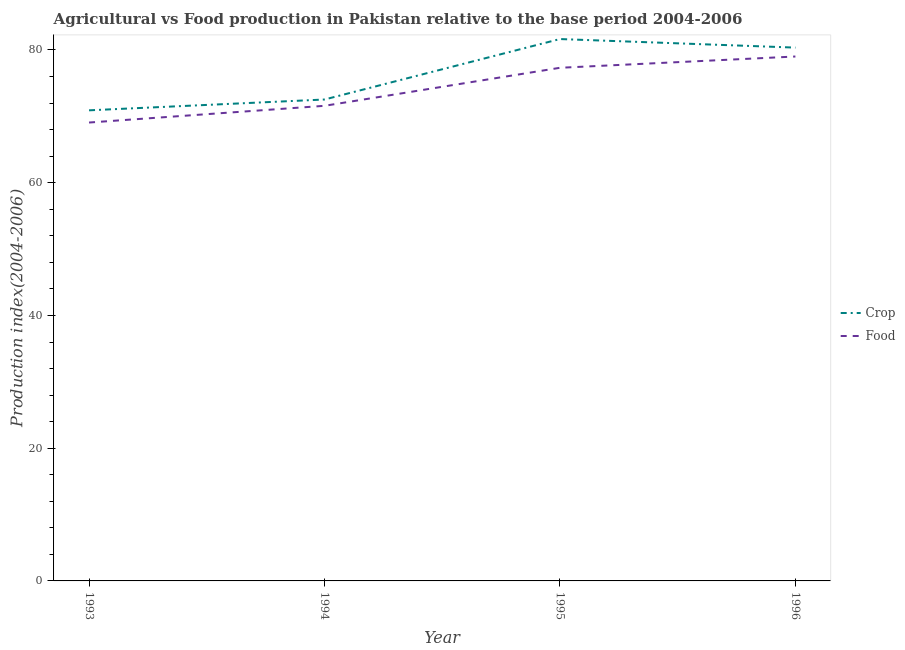What is the food production index in 1993?
Provide a short and direct response. 69.07. Across all years, what is the maximum crop production index?
Your answer should be compact. 81.65. Across all years, what is the minimum crop production index?
Offer a very short reply. 70.91. What is the total food production index in the graph?
Keep it short and to the point. 297. What is the difference between the food production index in 1994 and that in 1995?
Make the answer very short. -5.73. What is the difference between the food production index in 1996 and the crop production index in 1994?
Your answer should be compact. 6.48. What is the average crop production index per year?
Ensure brevity in your answer.  76.36. In the year 1996, what is the difference between the crop production index and food production index?
Offer a very short reply. 1.34. In how many years, is the crop production index greater than 56?
Offer a very short reply. 4. What is the ratio of the food production index in 1993 to that in 1994?
Give a very brief answer. 0.96. What is the difference between the highest and the second highest crop production index?
Offer a terse response. 1.29. What is the difference between the highest and the lowest food production index?
Offer a very short reply. 9.95. Is the food production index strictly greater than the crop production index over the years?
Your answer should be very brief. No. Is the crop production index strictly less than the food production index over the years?
Make the answer very short. No. How many years are there in the graph?
Your response must be concise. 4. Does the graph contain any zero values?
Give a very brief answer. No. Does the graph contain grids?
Your response must be concise. No. Where does the legend appear in the graph?
Keep it short and to the point. Center right. How many legend labels are there?
Offer a very short reply. 2. How are the legend labels stacked?
Provide a succinct answer. Vertical. What is the title of the graph?
Ensure brevity in your answer.  Agricultural vs Food production in Pakistan relative to the base period 2004-2006. What is the label or title of the X-axis?
Give a very brief answer. Year. What is the label or title of the Y-axis?
Offer a very short reply. Production index(2004-2006). What is the Production index(2004-2006) of Crop in 1993?
Offer a very short reply. 70.91. What is the Production index(2004-2006) in Food in 1993?
Make the answer very short. 69.07. What is the Production index(2004-2006) in Crop in 1994?
Provide a short and direct response. 72.54. What is the Production index(2004-2006) of Food in 1994?
Your answer should be compact. 71.59. What is the Production index(2004-2006) of Crop in 1995?
Offer a terse response. 81.65. What is the Production index(2004-2006) in Food in 1995?
Give a very brief answer. 77.32. What is the Production index(2004-2006) of Crop in 1996?
Give a very brief answer. 80.36. What is the Production index(2004-2006) in Food in 1996?
Offer a terse response. 79.02. Across all years, what is the maximum Production index(2004-2006) of Crop?
Your answer should be very brief. 81.65. Across all years, what is the maximum Production index(2004-2006) of Food?
Your answer should be compact. 79.02. Across all years, what is the minimum Production index(2004-2006) of Crop?
Your answer should be very brief. 70.91. Across all years, what is the minimum Production index(2004-2006) in Food?
Your answer should be compact. 69.07. What is the total Production index(2004-2006) in Crop in the graph?
Make the answer very short. 305.46. What is the total Production index(2004-2006) of Food in the graph?
Provide a succinct answer. 297. What is the difference between the Production index(2004-2006) of Crop in 1993 and that in 1994?
Your answer should be very brief. -1.63. What is the difference between the Production index(2004-2006) in Food in 1993 and that in 1994?
Your response must be concise. -2.52. What is the difference between the Production index(2004-2006) in Crop in 1993 and that in 1995?
Provide a succinct answer. -10.74. What is the difference between the Production index(2004-2006) of Food in 1993 and that in 1995?
Ensure brevity in your answer.  -8.25. What is the difference between the Production index(2004-2006) of Crop in 1993 and that in 1996?
Your response must be concise. -9.45. What is the difference between the Production index(2004-2006) in Food in 1993 and that in 1996?
Ensure brevity in your answer.  -9.95. What is the difference between the Production index(2004-2006) in Crop in 1994 and that in 1995?
Offer a terse response. -9.11. What is the difference between the Production index(2004-2006) of Food in 1994 and that in 1995?
Keep it short and to the point. -5.73. What is the difference between the Production index(2004-2006) in Crop in 1994 and that in 1996?
Provide a short and direct response. -7.82. What is the difference between the Production index(2004-2006) in Food in 1994 and that in 1996?
Your answer should be compact. -7.43. What is the difference between the Production index(2004-2006) in Crop in 1995 and that in 1996?
Provide a succinct answer. 1.29. What is the difference between the Production index(2004-2006) of Food in 1995 and that in 1996?
Keep it short and to the point. -1.7. What is the difference between the Production index(2004-2006) in Crop in 1993 and the Production index(2004-2006) in Food in 1994?
Your response must be concise. -0.68. What is the difference between the Production index(2004-2006) in Crop in 1993 and the Production index(2004-2006) in Food in 1995?
Offer a very short reply. -6.41. What is the difference between the Production index(2004-2006) of Crop in 1993 and the Production index(2004-2006) of Food in 1996?
Provide a short and direct response. -8.11. What is the difference between the Production index(2004-2006) in Crop in 1994 and the Production index(2004-2006) in Food in 1995?
Provide a short and direct response. -4.78. What is the difference between the Production index(2004-2006) in Crop in 1994 and the Production index(2004-2006) in Food in 1996?
Make the answer very short. -6.48. What is the difference between the Production index(2004-2006) of Crop in 1995 and the Production index(2004-2006) of Food in 1996?
Offer a terse response. 2.63. What is the average Production index(2004-2006) in Crop per year?
Your answer should be compact. 76.36. What is the average Production index(2004-2006) of Food per year?
Offer a terse response. 74.25. In the year 1993, what is the difference between the Production index(2004-2006) in Crop and Production index(2004-2006) in Food?
Offer a very short reply. 1.84. In the year 1994, what is the difference between the Production index(2004-2006) of Crop and Production index(2004-2006) of Food?
Keep it short and to the point. 0.95. In the year 1995, what is the difference between the Production index(2004-2006) in Crop and Production index(2004-2006) in Food?
Make the answer very short. 4.33. In the year 1996, what is the difference between the Production index(2004-2006) in Crop and Production index(2004-2006) in Food?
Give a very brief answer. 1.34. What is the ratio of the Production index(2004-2006) of Crop in 1993 to that in 1994?
Your answer should be very brief. 0.98. What is the ratio of the Production index(2004-2006) in Food in 1993 to that in 1994?
Offer a very short reply. 0.96. What is the ratio of the Production index(2004-2006) of Crop in 1993 to that in 1995?
Provide a succinct answer. 0.87. What is the ratio of the Production index(2004-2006) in Food in 1993 to that in 1995?
Give a very brief answer. 0.89. What is the ratio of the Production index(2004-2006) in Crop in 1993 to that in 1996?
Offer a very short reply. 0.88. What is the ratio of the Production index(2004-2006) in Food in 1993 to that in 1996?
Your answer should be compact. 0.87. What is the ratio of the Production index(2004-2006) in Crop in 1994 to that in 1995?
Provide a short and direct response. 0.89. What is the ratio of the Production index(2004-2006) of Food in 1994 to that in 1995?
Your response must be concise. 0.93. What is the ratio of the Production index(2004-2006) of Crop in 1994 to that in 1996?
Offer a terse response. 0.9. What is the ratio of the Production index(2004-2006) of Food in 1994 to that in 1996?
Offer a very short reply. 0.91. What is the ratio of the Production index(2004-2006) of Crop in 1995 to that in 1996?
Give a very brief answer. 1.02. What is the ratio of the Production index(2004-2006) of Food in 1995 to that in 1996?
Offer a terse response. 0.98. What is the difference between the highest and the second highest Production index(2004-2006) of Crop?
Offer a very short reply. 1.29. What is the difference between the highest and the lowest Production index(2004-2006) of Crop?
Ensure brevity in your answer.  10.74. What is the difference between the highest and the lowest Production index(2004-2006) of Food?
Your answer should be compact. 9.95. 